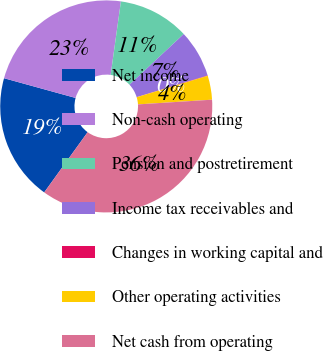Convert chart to OTSL. <chart><loc_0><loc_0><loc_500><loc_500><pie_chart><fcel>Net income<fcel>Non-cash operating<fcel>Pension and postretirement<fcel>Income tax receivables and<fcel>Changes in working capital and<fcel>Other operating activities<fcel>Net cash from operating<nl><fcel>19.34%<fcel>22.93%<fcel>10.83%<fcel>7.24%<fcel>0.06%<fcel>3.65%<fcel>35.96%<nl></chart> 